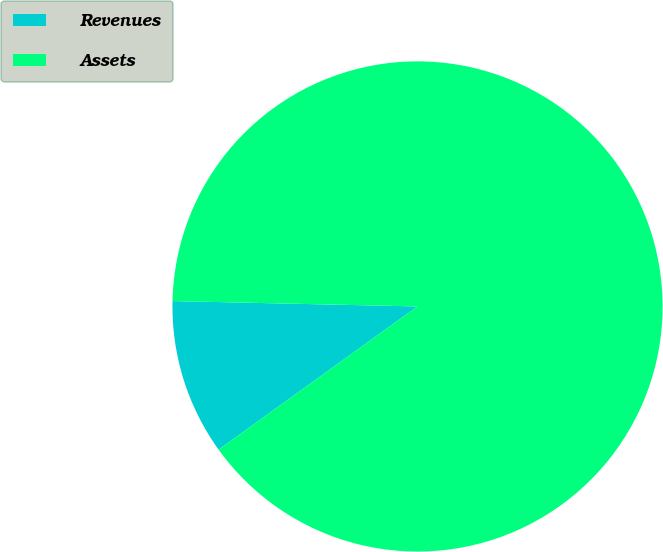Convert chart. <chart><loc_0><loc_0><loc_500><loc_500><pie_chart><fcel>Revenues<fcel>Assets<nl><fcel>10.28%<fcel>89.72%<nl></chart> 